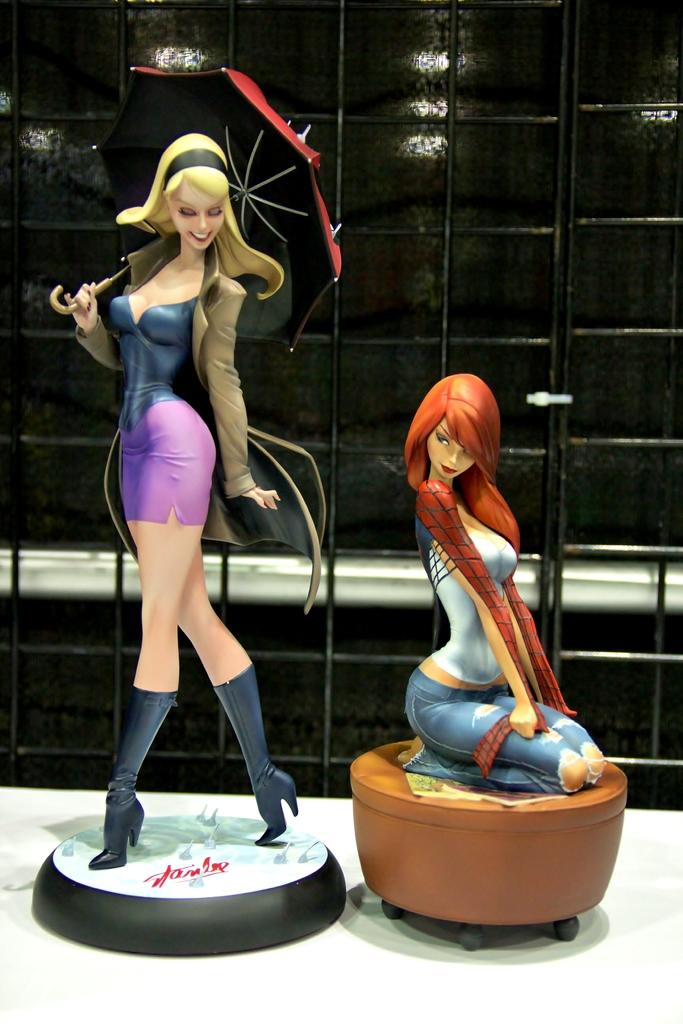How many women are in the image? There are two women depicted in the image. What are the women doing in the image? The women are on the floor. What can be seen in the background of the image? There is a glass wall in the background of the image. Where might this image have been taken? The image may have been taken in a showroom. What type of duck can be seen swimming in the image? There is no duck present in the image; it features two women on the floor with a glass wall in the background. How hot is the yam being served in the image? There is no yam or indication of temperature in the image. 